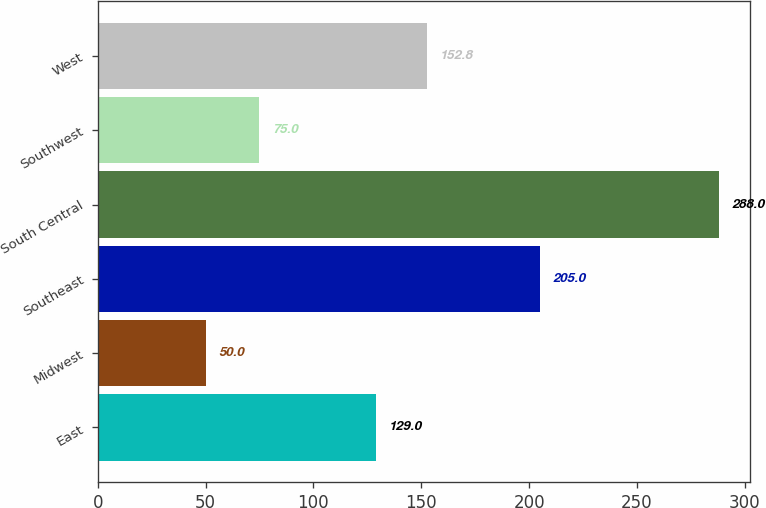<chart> <loc_0><loc_0><loc_500><loc_500><bar_chart><fcel>East<fcel>Midwest<fcel>Southeast<fcel>South Central<fcel>Southwest<fcel>West<nl><fcel>129<fcel>50<fcel>205<fcel>288<fcel>75<fcel>152.8<nl></chart> 